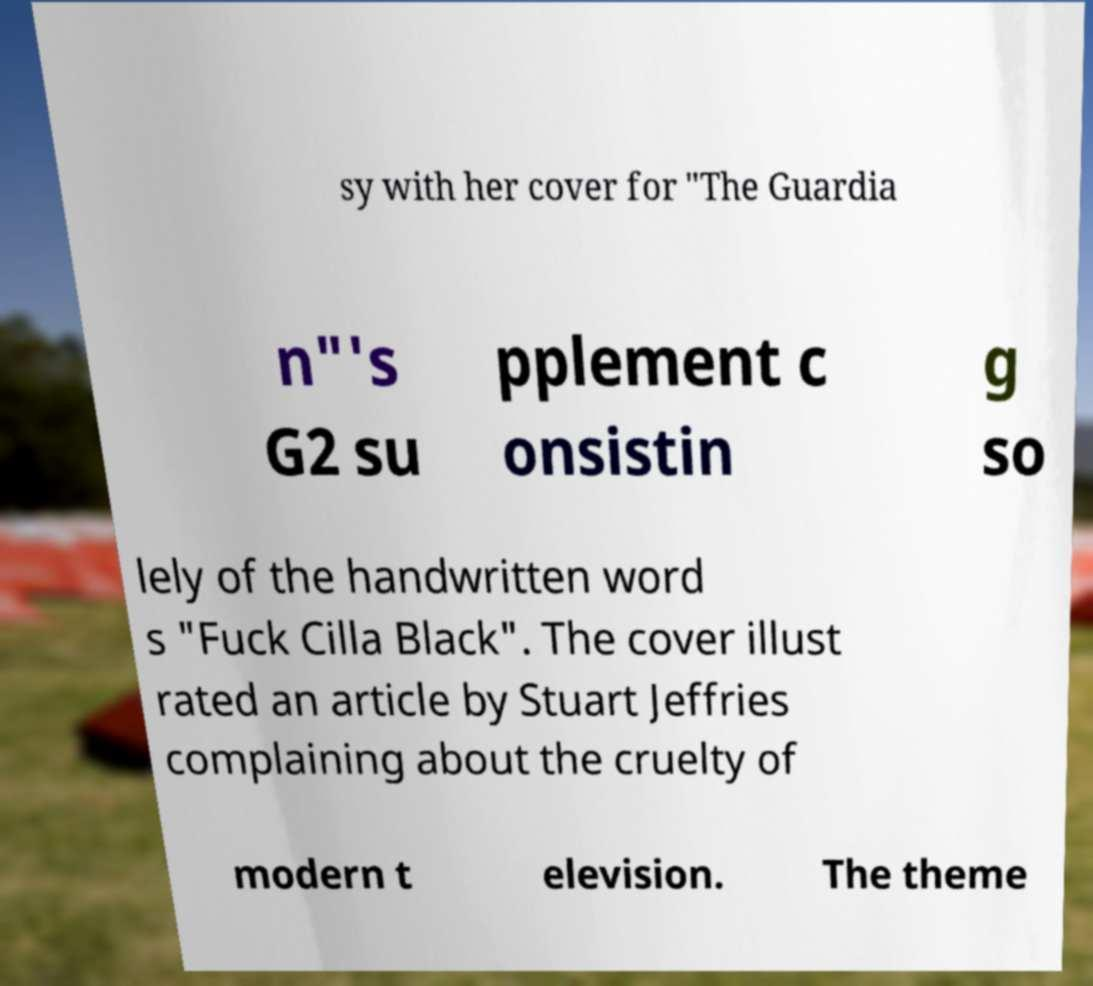Can you accurately transcribe the text from the provided image for me? sy with her cover for "The Guardia n"'s G2 su pplement c onsistin g so lely of the handwritten word s "Fuck Cilla Black". The cover illust rated an article by Stuart Jeffries complaining about the cruelty of modern t elevision. The theme 